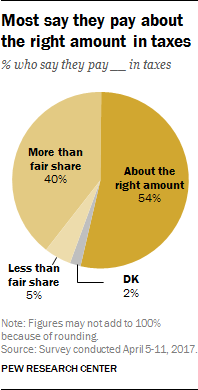Specify some key components in this picture. The smallest section of the chart is colored gray. The average of the three biggest values in the chart is 33. 